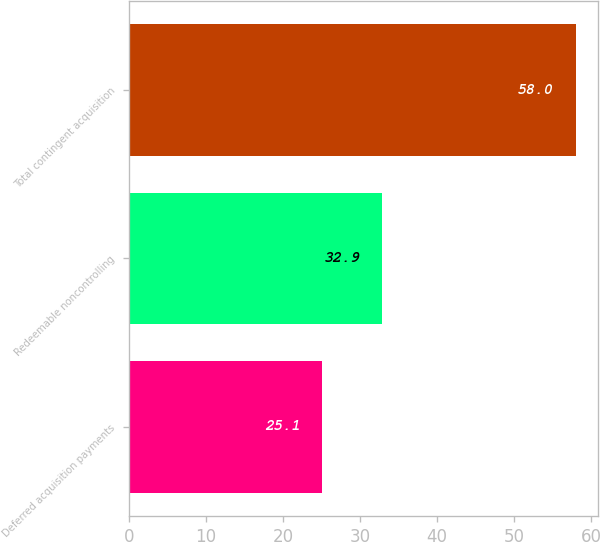Convert chart. <chart><loc_0><loc_0><loc_500><loc_500><bar_chart><fcel>Deferred acquisition payments<fcel>Redeemable noncontrolling<fcel>Total contingent acquisition<nl><fcel>25.1<fcel>32.9<fcel>58<nl></chart> 